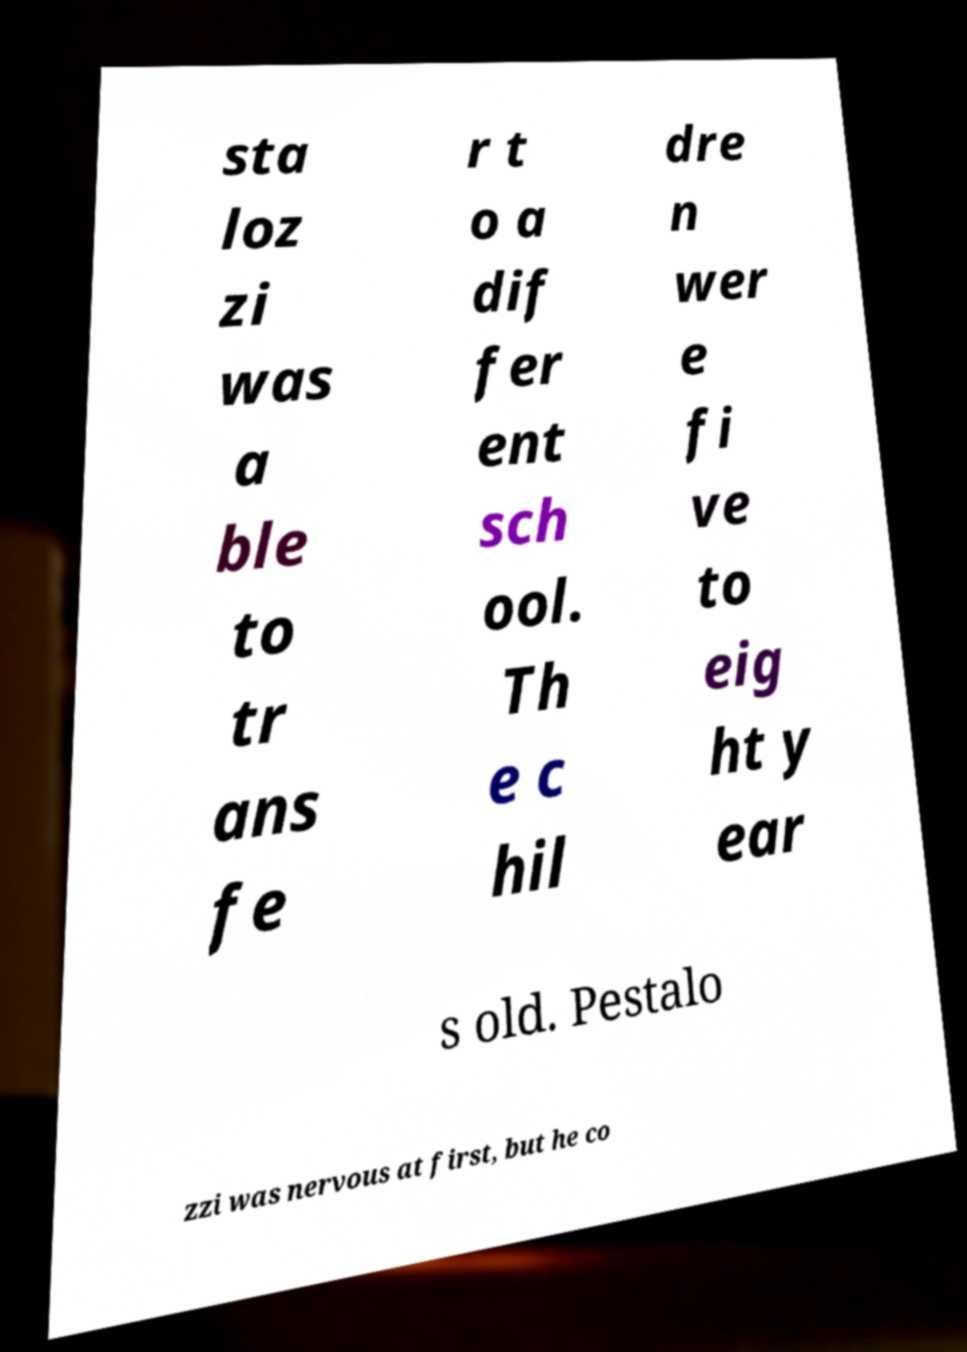Please read and relay the text visible in this image. What does it say? sta loz zi was a ble to tr ans fe r t o a dif fer ent sch ool. Th e c hil dre n wer e fi ve to eig ht y ear s old. Pestalo zzi was nervous at first, but he co 